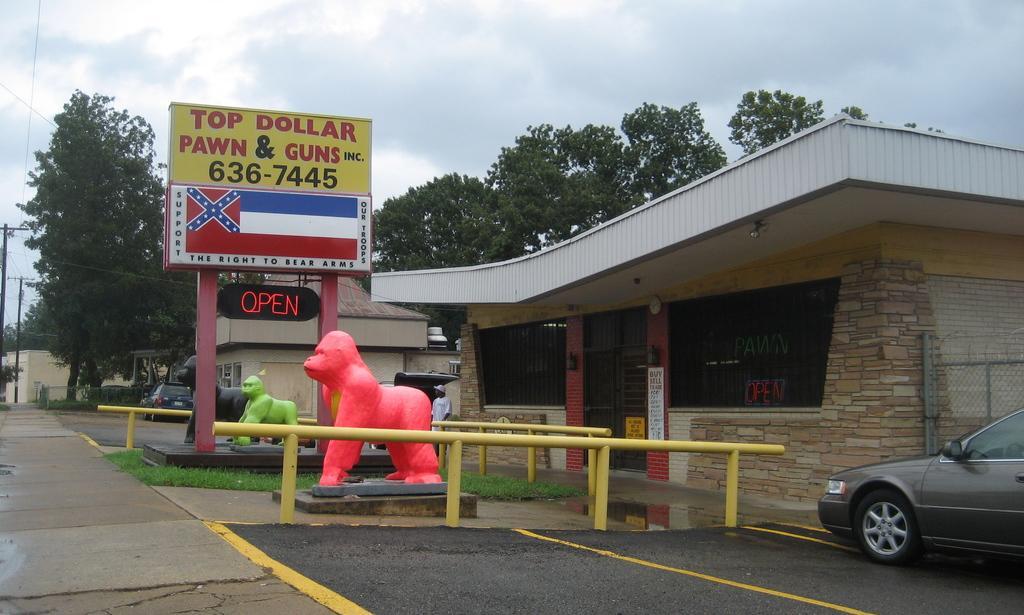How would you summarize this image in a sentence or two? In this image we can see a few buildings, there are some vehicles, trees, sculptures, poles, windows and doors, also we can see a person and a board with some text, in the background we can see the sky with clouds. 